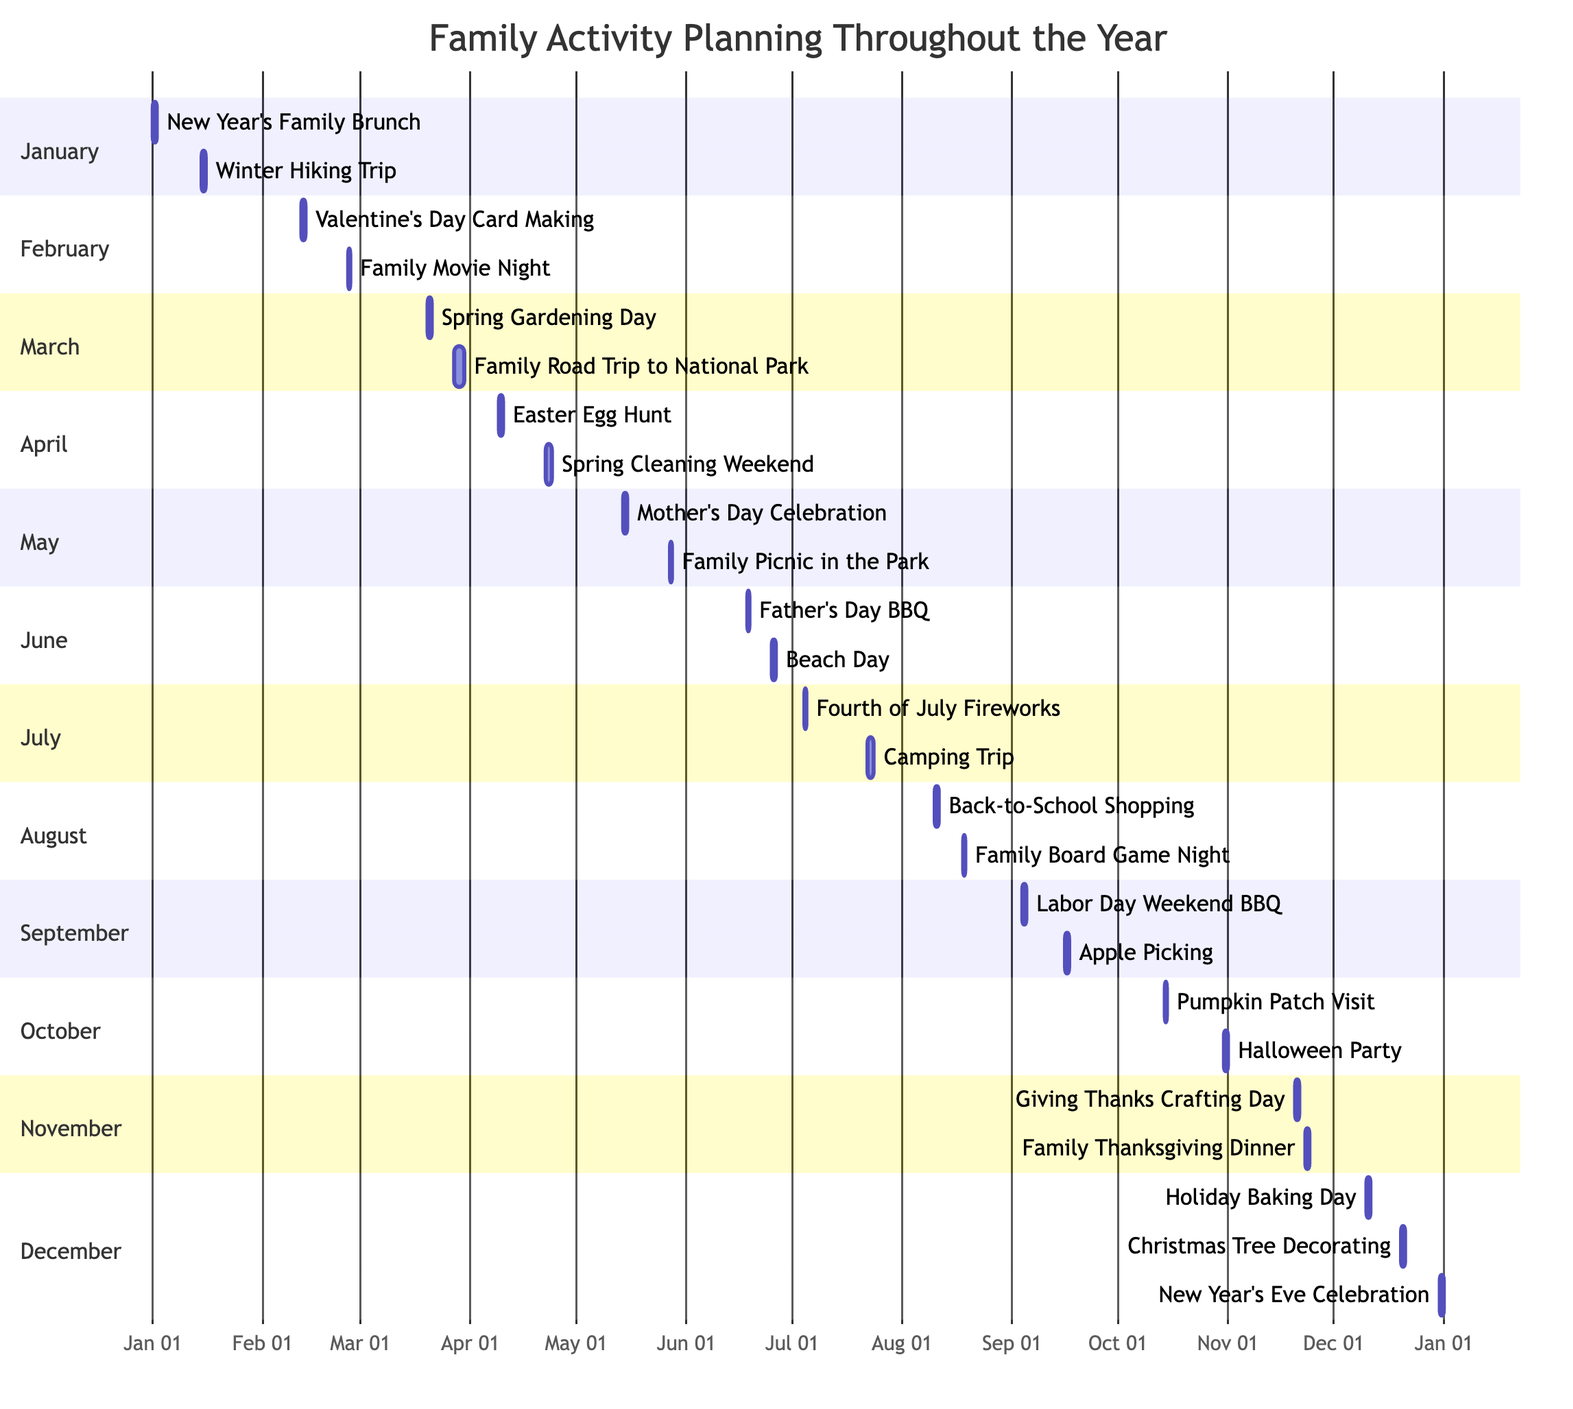What activities are planned for May? The Gantt Chart shows two activities planned for May: "Mother's Day Celebration" and "Family Picnic in the Park."
Answer: Mother's Day Celebration, Family Picnic in the Park How many activities are scheduled in June? In June, there are two activities listed: "Father's Day BBQ" and "Beach Day," making a total of two activities in that month.
Answer: 2 What is the longest activity duration? Looking at the Gantt Chart, the "Family Road Trip to National Park" spans three days, which is longer than any other activity listed.
Answer: 3 days When is the Halloween Party scheduled? The Gantt Chart indicates that the "Halloween Party" is scheduled for October 31, 2023, as marked on the timeline for October.
Answer: October 31 Which activity occurs first in the year? The first activity on the Gantt Chart is the "New Year's Family Brunch," which takes place on January 1, 2023.
Answer: New Year's Family Brunch What event is happening just before Thanksgiving? The Gantt Chart shows that the "Giving Thanks Crafting Day" occurs on November 20, three days before "Family Thanksgiving Dinner" on November 23.
Answer: Giving Thanks Crafting Day Which month features a camping trip? The Gantt Chart lists a "Camping Trip" in July, specifically scheduled for July 22, 2023.
Answer: July Is there any event scheduled in September? Yes, there are two activities scheduled in September: "Labor Day Weekend BBQ" on September 4 and "Apple Picking" on September 16.
Answer: Yes What family activity is on December 20? According to the Gantt Chart, the "Christmas Tree Decorating" activity is set for December 20, 2023.
Answer: Christmas Tree Decorating 